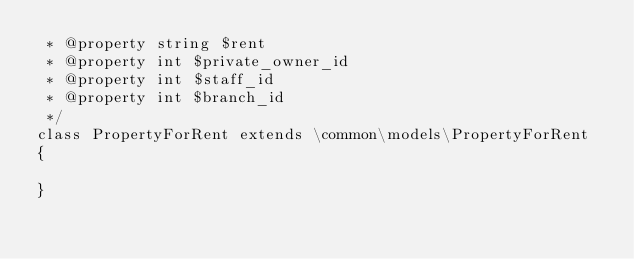<code> <loc_0><loc_0><loc_500><loc_500><_PHP_> * @property string $rent
 * @property int $private_owner_id
 * @property int $staff_id
 * @property int $branch_id
 */
class PropertyForRent extends \common\models\PropertyForRent
{
    
}
</code> 